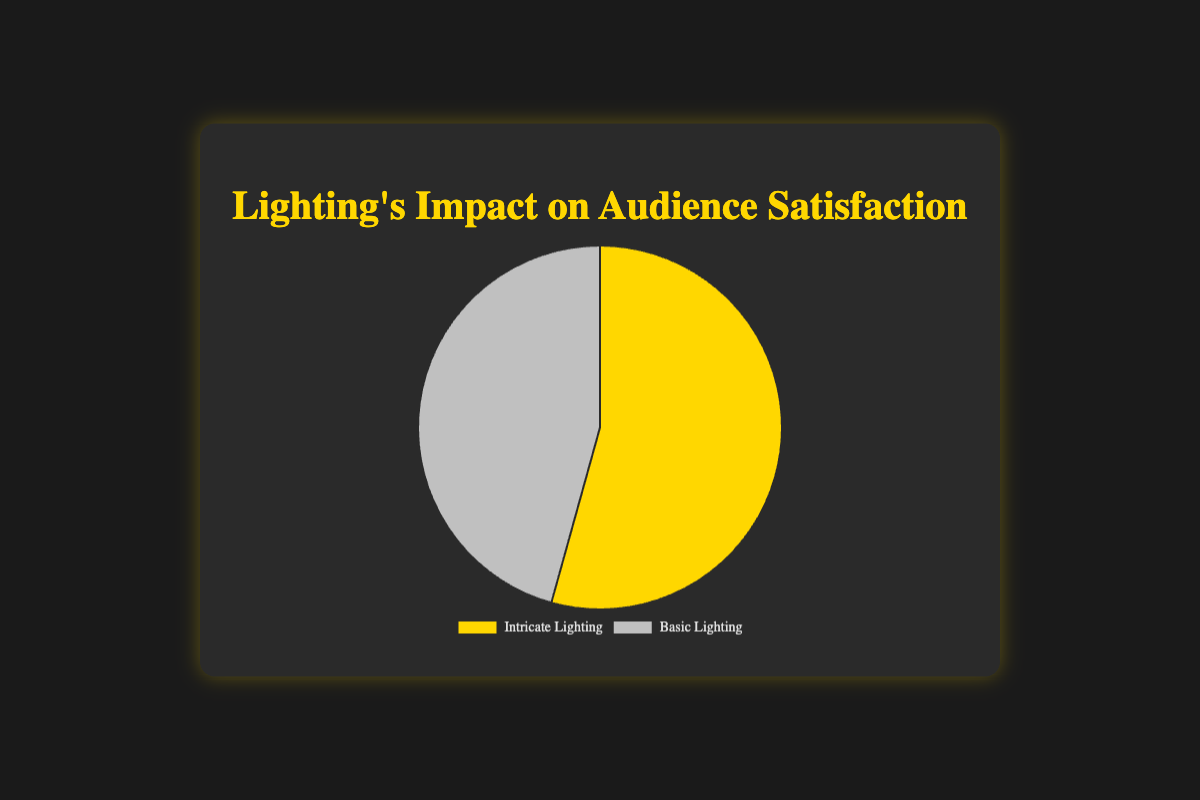What are the average audience satisfaction ratings for shows with intricate and basic lighting? First, sum the audience satisfaction ratings for each lighting type: Intricate (95 + 92 + 90) = 277, Basic (80 + 75 + 78) = 233. Next, divide each sum by the number of shows: Intricate (277/3 ≈ 92.33), Basic (233/3 ≈ 77.67)
Answer: Intricate: 92.33, Basic: 77.67 Which type of lighting has a higher average audience satisfaction rating? By comparing the average ratings, Intricate lighting (92.33) is higher than Basic lighting (77.67)
Answer: Intricate lighting What is the difference in average audience satisfaction between intricate and basic lighting? Subtract the average rating of Basic lighting from Intricate lighting: 92.33 - 77.67 ≈ 14.66
Answer: 14.66 What percentage of the total average satisfaction is attributed to intricate lighting? Sum the averages of both lightings: 92.33 + 77.67 = 170. Divide the average of Intricate lighting by this total and multiply by 100 for the percentage: (92.33 / 170) * 100 ≈ 54.31%
Answer: 54.31% Which section has a pie chart slice colored in gold? The chart shows intricate lighting denoted with a gold-colored slice
Answer: Intricate lighting Which type of lighting represents the majority in audience satisfaction ratings? The data shows that Intricate lighting has 92.33% while Basic lighting has 77.67% and the slice for Intricate is larger
Answer: Intricate lighting What is the sum of average audience satisfaction ratings for all shows combined? Add the average satisfaction ratings for both intricate and basic lighting: 92.33 + 77.67 = 170
Answer: 170 What is the least average audience satisfaction rating percentage shown in the diagram? Basic lighting has the lower average rating at 77.67%
Answer: 77.67% How does the pie chart depict the audience satisfaction difference visually? The chart uses color and slice size to display the difference, with intricate lighting in gold showing a larger percentage than basic lighting in silver
Answer: Via larger gold slice Compare the average differences in ratings between the highest-rated intricate lighting show and the lowest-rated basic lighting show. The highest rating for intricate is 95, and the lowest for basic is 75. The difference is 95 - 75 = 20
Answer: 20 